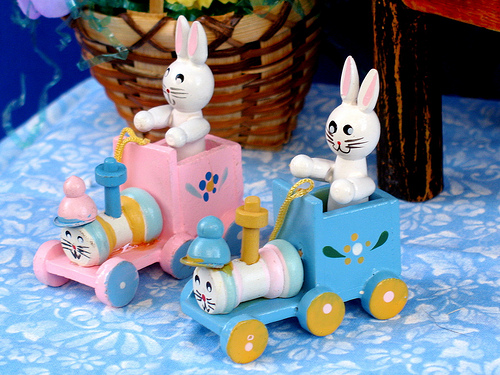<image>
Is there a bunny on the train? Yes. Looking at the image, I can see the bunny is positioned on top of the train, with the train providing support. 